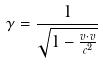<formula> <loc_0><loc_0><loc_500><loc_500>\gamma = \frac { 1 } { \sqrt { 1 - \frac { v \cdot v } { c ^ { 2 } } } }</formula> 